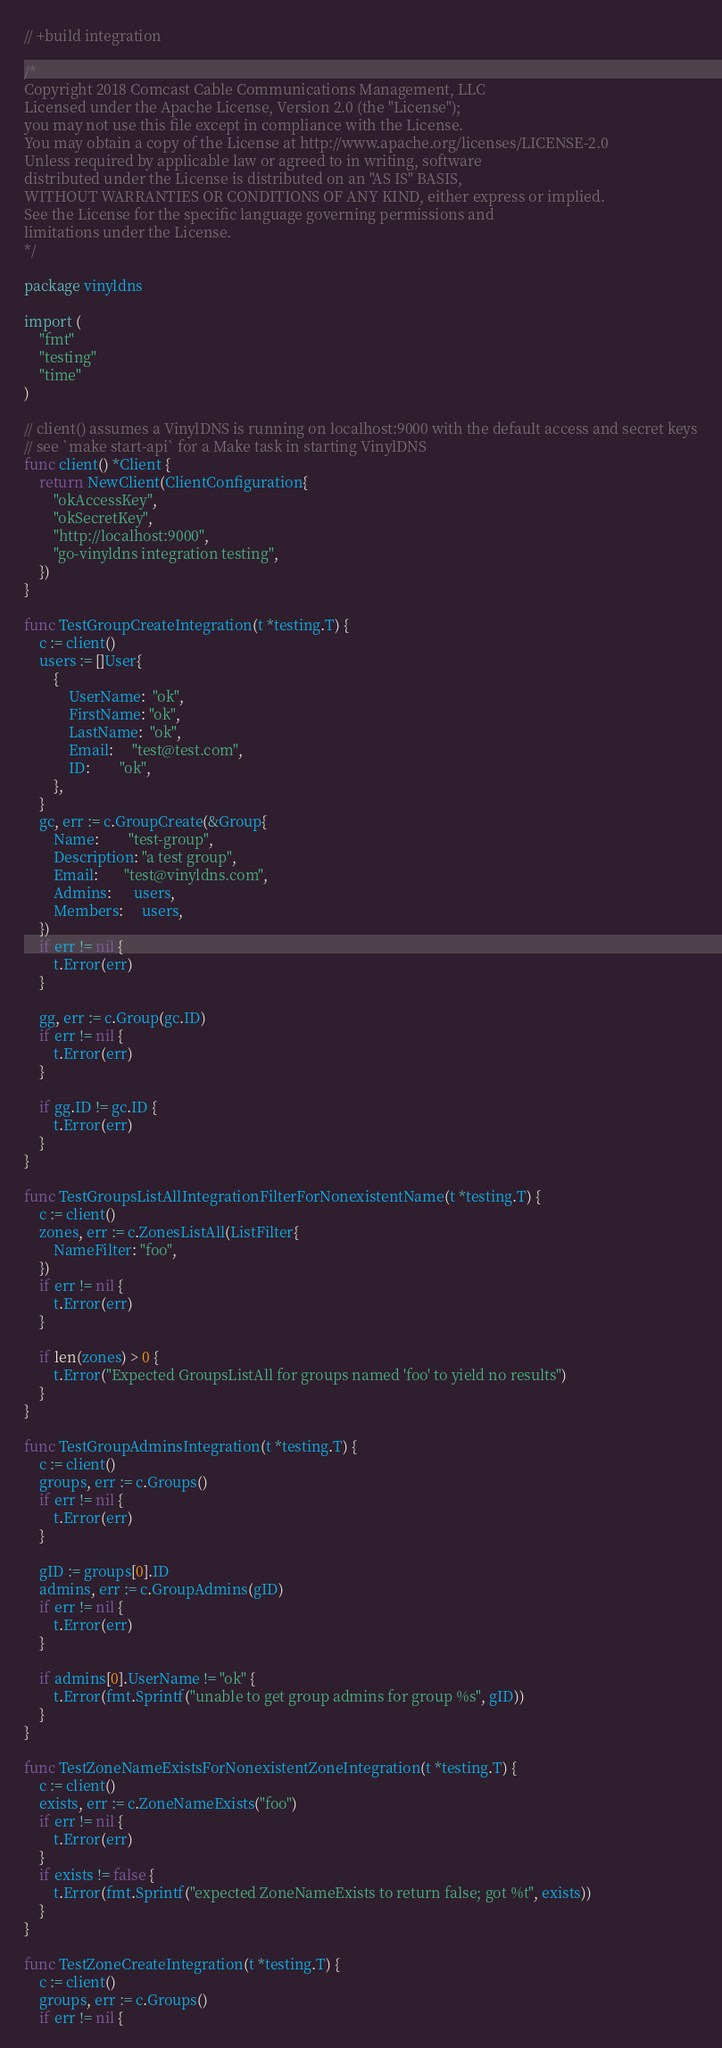<code> <loc_0><loc_0><loc_500><loc_500><_Go_>// +build integration

/*
Copyright 2018 Comcast Cable Communications Management, LLC
Licensed under the Apache License, Version 2.0 (the "License");
you may not use this file except in compliance with the License.
You may obtain a copy of the License at http://www.apache.org/licenses/LICENSE-2.0
Unless required by applicable law or agreed to in writing, software
distributed under the License is distributed on an "AS IS" BASIS,
WITHOUT WARRANTIES OR CONDITIONS OF ANY KIND, either express or implied.
See the License for the specific language governing permissions and
limitations under the License.
*/

package vinyldns

import (
	"fmt"
	"testing"
	"time"
)

// client() assumes a VinylDNS is running on localhost:9000 with the default access and secret keys
// see `make start-api` for a Make task in starting VinylDNS
func client() *Client {
	return NewClient(ClientConfiguration{
		"okAccessKey",
		"okSecretKey",
		"http://localhost:9000",
		"go-vinyldns integration testing",
	})
}

func TestGroupCreateIntegration(t *testing.T) {
	c := client()
	users := []User{
		{
			UserName:  "ok",
			FirstName: "ok",
			LastName:  "ok",
			Email:     "test@test.com",
			ID:        "ok",
		},
	}
	gc, err := c.GroupCreate(&Group{
		Name:        "test-group",
		Description: "a test group",
		Email:       "test@vinyldns.com",
		Admins:      users,
		Members:     users,
	})
	if err != nil {
		t.Error(err)
	}

	gg, err := c.Group(gc.ID)
	if err != nil {
		t.Error(err)
	}

	if gg.ID != gc.ID {
		t.Error(err)
	}
}

func TestGroupsListAllIntegrationFilterForNonexistentName(t *testing.T) {
	c := client()
	zones, err := c.ZonesListAll(ListFilter{
		NameFilter: "foo",
	})
	if err != nil {
		t.Error(err)
	}

	if len(zones) > 0 {
		t.Error("Expected GroupsListAll for groups named 'foo' to yield no results")
	}
}

func TestGroupAdminsIntegration(t *testing.T) {
	c := client()
	groups, err := c.Groups()
	if err != nil {
		t.Error(err)
	}

	gID := groups[0].ID
	admins, err := c.GroupAdmins(gID)
	if err != nil {
		t.Error(err)
	}

	if admins[0].UserName != "ok" {
		t.Error(fmt.Sprintf("unable to get group admins for group %s", gID))
	}
}

func TestZoneNameExistsForNonexistentZoneIntegration(t *testing.T) {
	c := client()
	exists, err := c.ZoneNameExists("foo")
	if err != nil {
		t.Error(err)
	}
	if exists != false {
		t.Error(fmt.Sprintf("expected ZoneNameExists to return false; got %t", exists))
	}
}

func TestZoneCreateIntegration(t *testing.T) {
	c := client()
	groups, err := c.Groups()
	if err != nil {</code> 